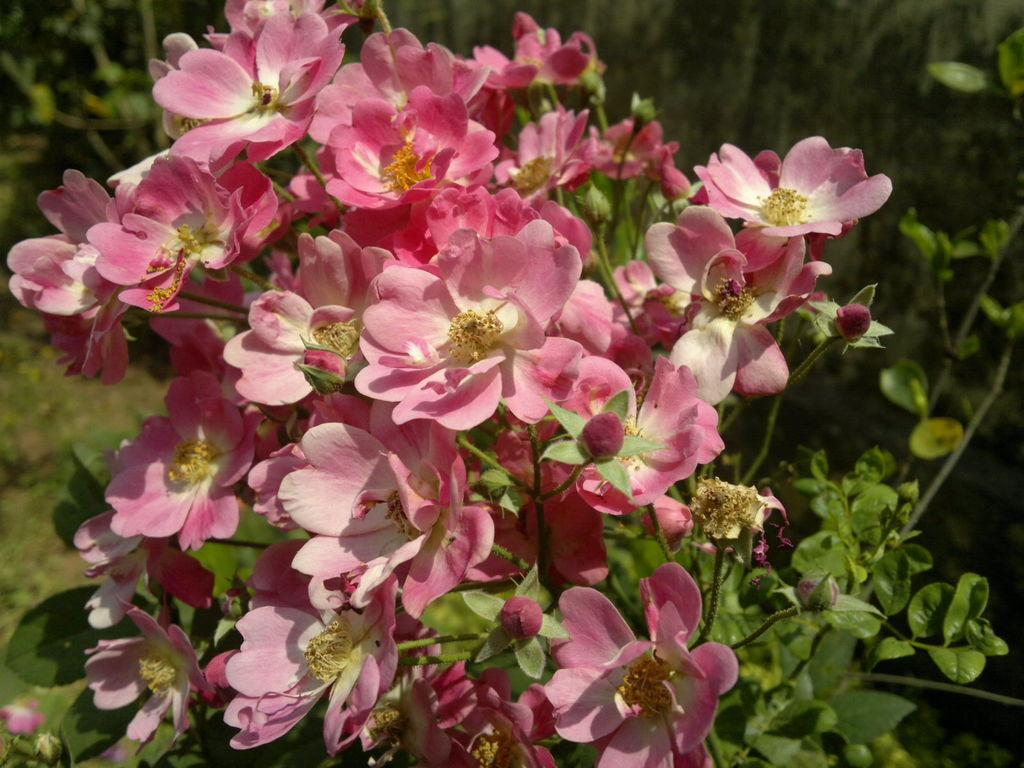What type of living organisms can be seen in the image? Plants and flowers are visible in the image. What color are the flowers in the image? The flowers in the image are pink in color. Can you tell me how many tigers are hiding among the flowers in the image? There are no tigers present in the image; it features plants and flowers. What type of glove can be seen on the flowers in the image? There is no glove present on the flowers in the image. 